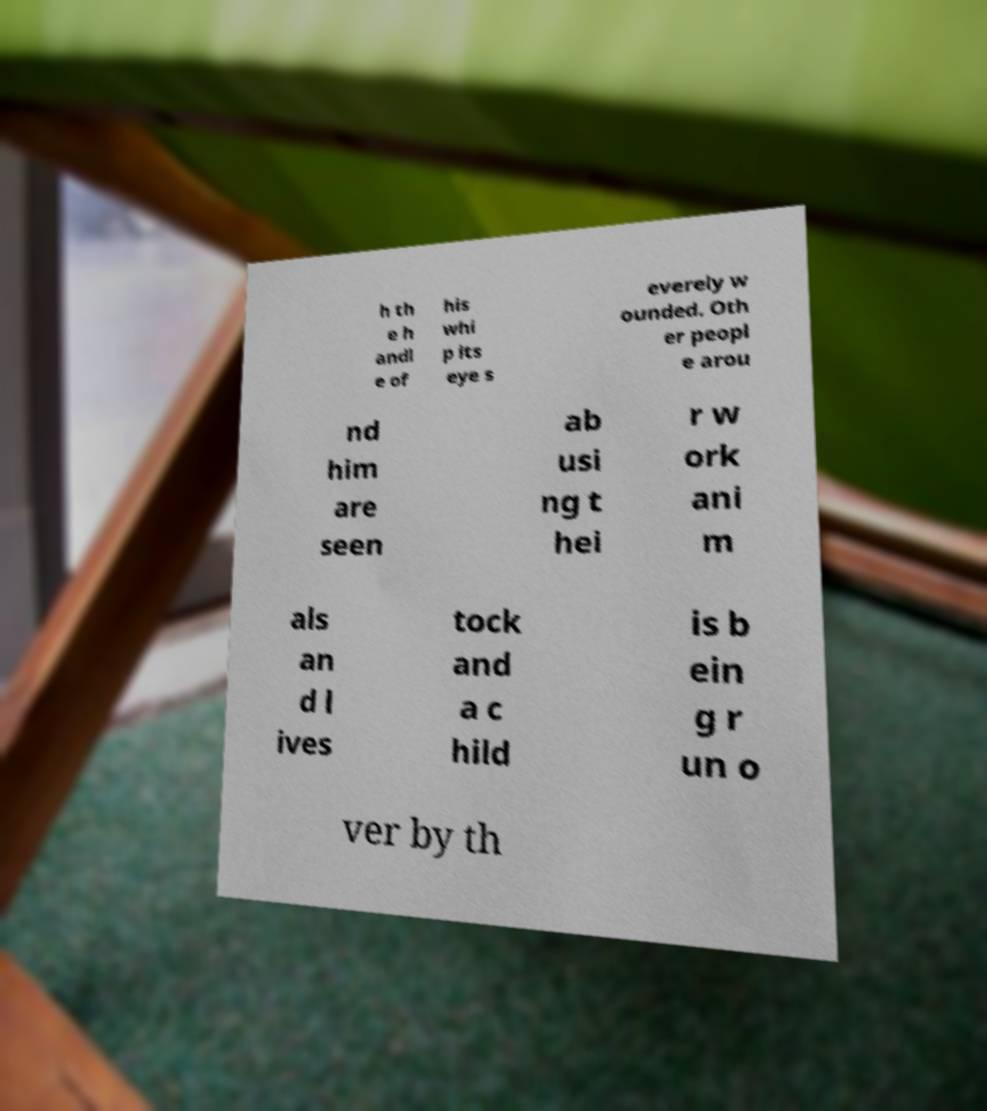Could you extract and type out the text from this image? h th e h andl e of his whi p its eye s everely w ounded. Oth er peopl e arou nd him are seen ab usi ng t hei r w ork ani m als an d l ives tock and a c hild is b ein g r un o ver by th 